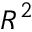Convert formula to latex. <formula><loc_0><loc_0><loc_500><loc_500>R ^ { 2 }</formula> 